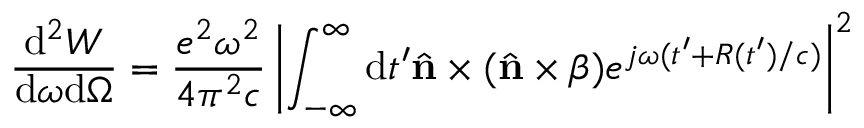Convert formula to latex. <formula><loc_0><loc_0><loc_500><loc_500>\frac { d ^ { 2 } W } { d \omega d \Omega } = \frac { e ^ { 2 } \omega ^ { 2 } } { 4 \pi ^ { 2 } c } \left | \int _ { - \infty } ^ { \infty } d t ^ { \prime } { \hat { n } \times ( \hat { n } \times \beta ) } e ^ { j \omega ( t ^ { \prime } + R ( t ^ { \prime } ) / c ) } \right | ^ { 2 }</formula> 